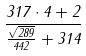Convert formula to latex. <formula><loc_0><loc_0><loc_500><loc_500>\frac { 3 1 7 \cdot 4 + 2 } { \frac { \sqrt { 2 8 9 } } { 4 4 2 } + 3 1 4 }</formula> 